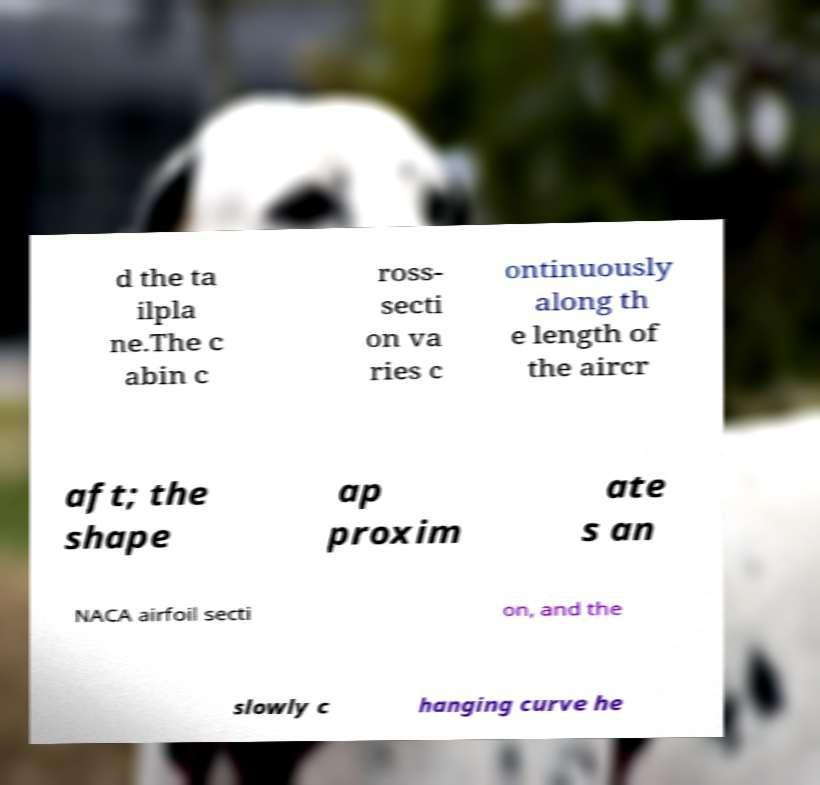Could you assist in decoding the text presented in this image and type it out clearly? d the ta ilpla ne.The c abin c ross- secti on va ries c ontinuously along th e length of the aircr aft; the shape ap proxim ate s an NACA airfoil secti on, and the slowly c hanging curve he 